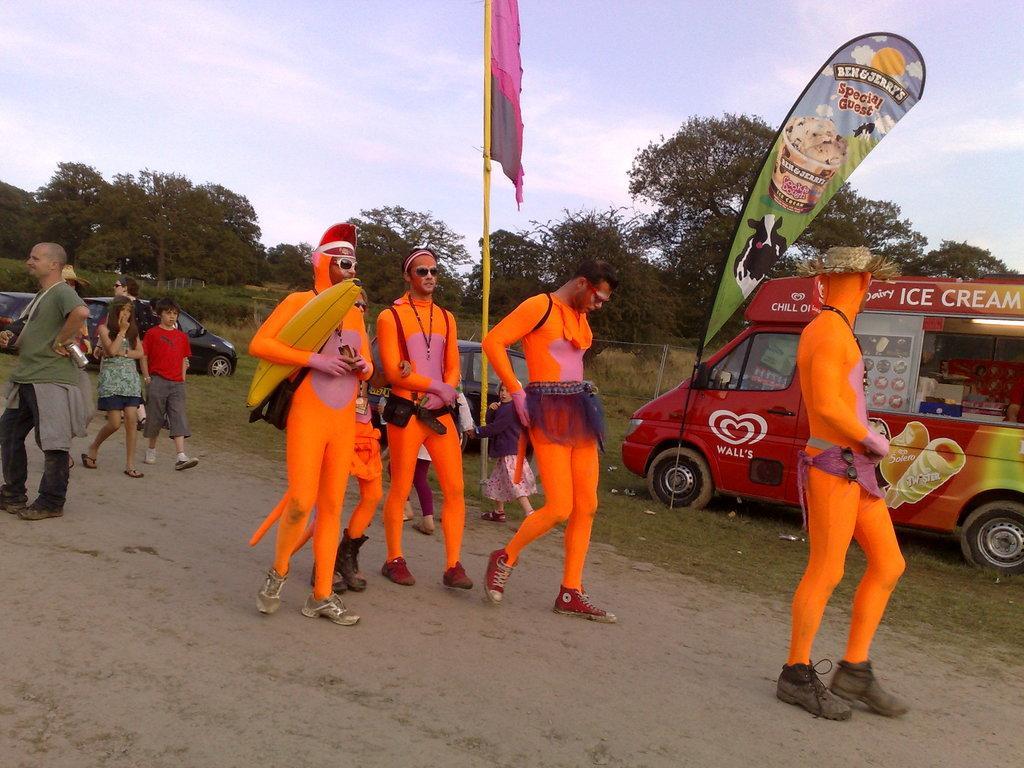In one or two sentences, can you explain what this image depicts? In this picture we can see a group of people and some of them were costumes and walking on the road, flag, banner, cars and a vehicle on the grass, trees and in the background we can see the sky. 